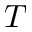<formula> <loc_0><loc_0><loc_500><loc_500>T</formula> 